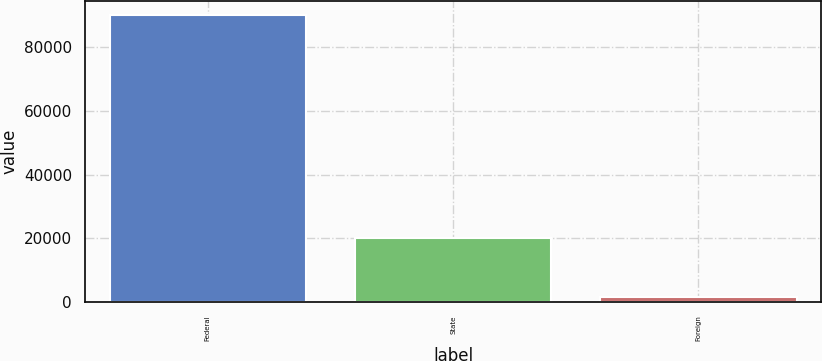Convert chart to OTSL. <chart><loc_0><loc_0><loc_500><loc_500><bar_chart><fcel>Federal<fcel>State<fcel>Foreign<nl><fcel>90018<fcel>20021<fcel>1537<nl></chart> 